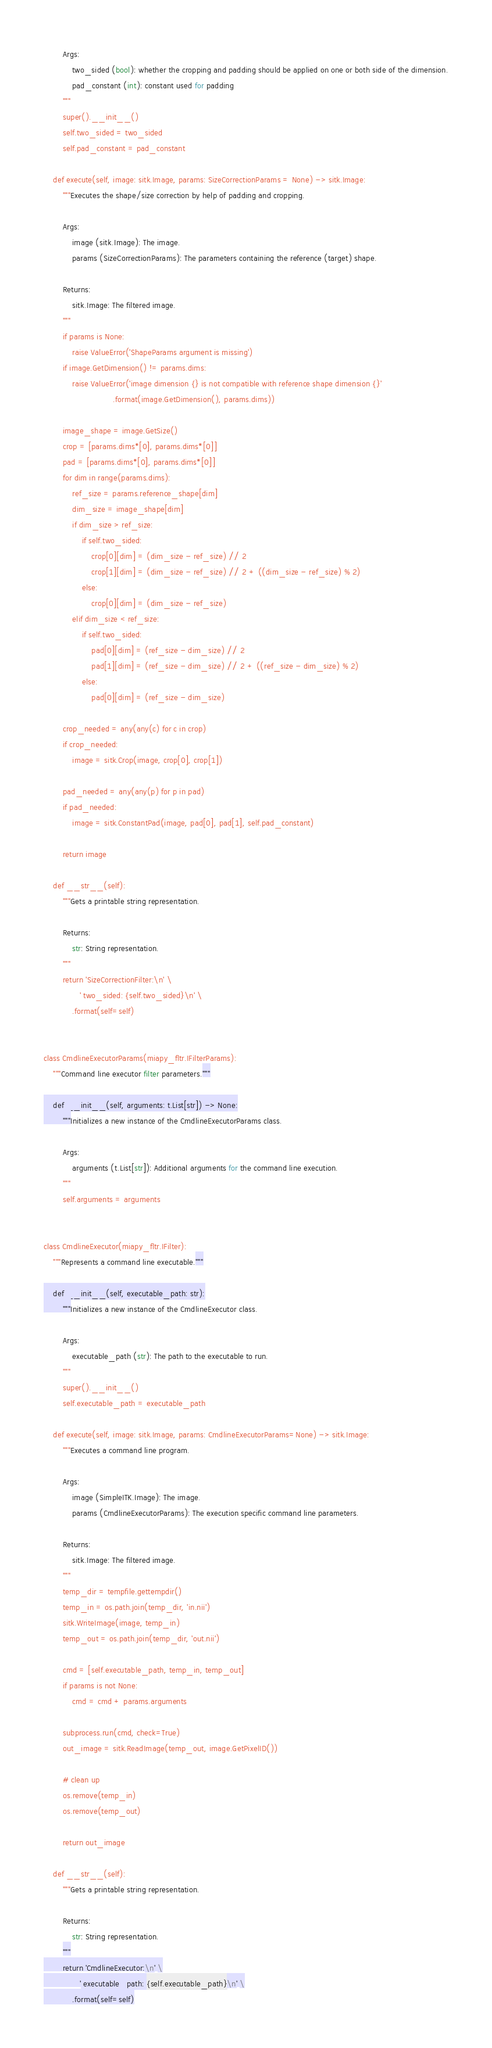<code> <loc_0><loc_0><loc_500><loc_500><_Python_>        Args:
            two_sided (bool): whether the cropping and padding should be applied on one or both side of the dimension.
            pad_constant (int): constant used for padding
        """
        super().__init__()
        self.two_sided = two_sided
        self.pad_constant = pad_constant

    def execute(self, image: sitk.Image, params: SizeCorrectionParams = None) -> sitk.Image:
        """Executes the shape/size correction by help of padding and cropping.

        Args:
            image (sitk.Image): The image.
            params (SizeCorrectionParams): The parameters containing the reference (target) shape.

        Returns:
            sitk.Image: The filtered image.
        """
        if params is None:
            raise ValueError('ShapeParams argument is missing')
        if image.GetDimension() != params.dims:
            raise ValueError('image dimension {} is not compatible with reference shape dimension {}'
                             .format(image.GetDimension(), params.dims))

        image_shape = image.GetSize()
        crop = [params.dims*[0], params.dims*[0]]
        pad = [params.dims*[0], params.dims*[0]]
        for dim in range(params.dims):
            ref_size = params.reference_shape[dim]
            dim_size = image_shape[dim]
            if dim_size > ref_size:
                if self.two_sided:
                    crop[0][dim] = (dim_size - ref_size) // 2
                    crop[1][dim] = (dim_size - ref_size) // 2 + ((dim_size - ref_size) % 2)
                else:
                    crop[0][dim] = (dim_size - ref_size)
            elif dim_size < ref_size:
                if self.two_sided:
                    pad[0][dim] = (ref_size - dim_size) // 2
                    pad[1][dim] = (ref_size - dim_size) // 2 + ((ref_size - dim_size) % 2)
                else:
                    pad[0][dim] = (ref_size - dim_size)

        crop_needed = any(any(c) for c in crop)
        if crop_needed:
            image = sitk.Crop(image, crop[0], crop[1])

        pad_needed = any(any(p) for p in pad)
        if pad_needed:
            image = sitk.ConstantPad(image, pad[0], pad[1], self.pad_constant)

        return image

    def __str__(self):
        """Gets a printable string representation.

        Returns:
            str: String representation.
        """
        return 'SizeCorrectionFilter:\n' \
               ' two_sided: {self.two_sided}\n' \
            .format(self=self)


class CmdlineExecutorParams(miapy_fltr.IFilterParams):
    """Command line executor filter parameters."""

    def __init__(self, arguments: t.List[str]) -> None:
        """Initializes a new instance of the CmdlineExecutorParams class.

        Args:
            arguments (t.List[str]): Additional arguments for the command line execution.
        """
        self.arguments = arguments


class CmdlineExecutor(miapy_fltr.IFilter):
    """Represents a command line executable."""

    def __init__(self, executable_path: str):
        """Initializes a new instance of the CmdlineExecutor class.

        Args:
            executable_path (str): The path to the executable to run.
        """
        super().__init__()
        self.executable_path = executable_path

    def execute(self, image: sitk.Image, params: CmdlineExecutorParams=None) -> sitk.Image:
        """Executes a command line program.

        Args:
            image (SimpleITK.Image): The image.
            params (CmdlineExecutorParams): The execution specific command line parameters.

        Returns:
            sitk.Image: The filtered image.
        """
        temp_dir = tempfile.gettempdir()
        temp_in = os.path.join(temp_dir, 'in.nii')
        sitk.WriteImage(image, temp_in)
        temp_out = os.path.join(temp_dir, 'out.nii')
        
        cmd = [self.executable_path, temp_in, temp_out]
        if params is not None:
            cmd = cmd + params.arguments
        
        subprocess.run(cmd, check=True)
        out_image = sitk.ReadImage(temp_out, image.GetPixelID())

        # clean up
        os.remove(temp_in)
        os.remove(temp_out)

        return out_image

    def __str__(self):
        """Gets a printable string representation.

        Returns:
            str: String representation.
        """
        return 'CmdlineExecutor:\n' \
               ' executable_path: {self.executable_path}\n' \
            .format(self=self)
</code> 